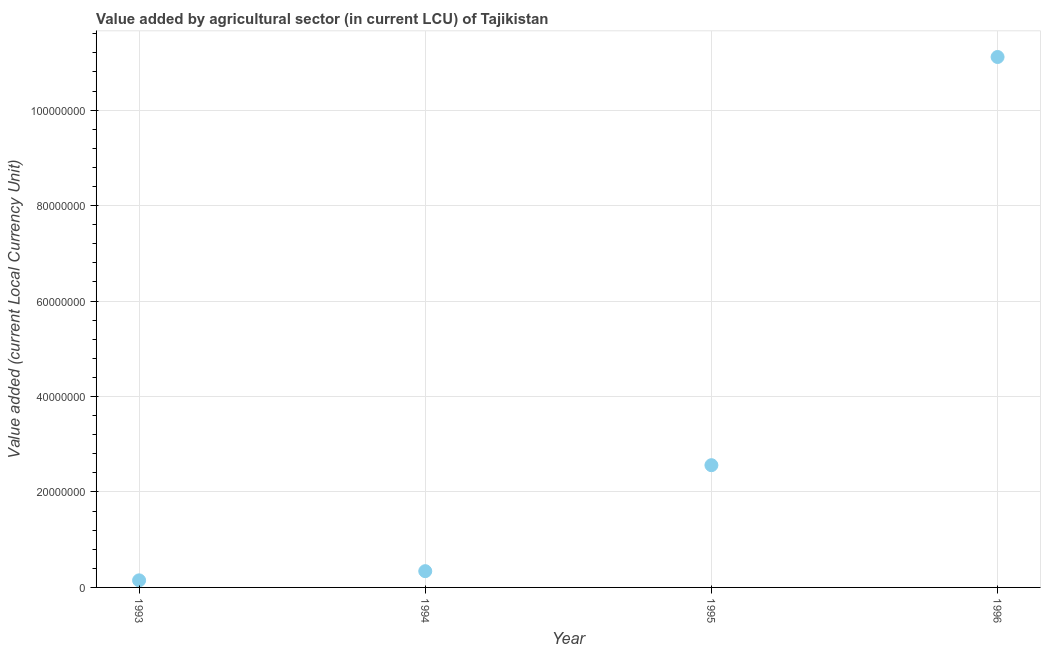What is the value added by agriculture sector in 1994?
Your answer should be very brief. 3.41e+06. Across all years, what is the maximum value added by agriculture sector?
Offer a very short reply. 1.11e+08. Across all years, what is the minimum value added by agriculture sector?
Offer a very short reply. 1.48e+06. In which year was the value added by agriculture sector minimum?
Ensure brevity in your answer.  1993. What is the sum of the value added by agriculture sector?
Your response must be concise. 1.42e+08. What is the difference between the value added by agriculture sector in 1993 and 1995?
Your answer should be very brief. -2.41e+07. What is the average value added by agriculture sector per year?
Ensure brevity in your answer.  3.54e+07. What is the median value added by agriculture sector?
Your response must be concise. 1.45e+07. In how many years, is the value added by agriculture sector greater than 104000000 LCU?
Give a very brief answer. 1. What is the ratio of the value added by agriculture sector in 1993 to that in 1996?
Provide a succinct answer. 0.01. Is the value added by agriculture sector in 1995 less than that in 1996?
Your answer should be very brief. Yes. Is the difference between the value added by agriculture sector in 1993 and 1995 greater than the difference between any two years?
Keep it short and to the point. No. What is the difference between the highest and the second highest value added by agriculture sector?
Provide a succinct answer. 8.55e+07. What is the difference between the highest and the lowest value added by agriculture sector?
Offer a very short reply. 1.10e+08. Does the value added by agriculture sector monotonically increase over the years?
Keep it short and to the point. Yes. How many dotlines are there?
Ensure brevity in your answer.  1. How many years are there in the graph?
Provide a succinct answer. 4. What is the difference between two consecutive major ticks on the Y-axis?
Keep it short and to the point. 2.00e+07. Are the values on the major ticks of Y-axis written in scientific E-notation?
Ensure brevity in your answer.  No. Does the graph contain any zero values?
Give a very brief answer. No. What is the title of the graph?
Offer a very short reply. Value added by agricultural sector (in current LCU) of Tajikistan. What is the label or title of the X-axis?
Your response must be concise. Year. What is the label or title of the Y-axis?
Your response must be concise. Value added (current Local Currency Unit). What is the Value added (current Local Currency Unit) in 1993?
Provide a short and direct response. 1.48e+06. What is the Value added (current Local Currency Unit) in 1994?
Your answer should be very brief. 3.41e+06. What is the Value added (current Local Currency Unit) in 1995?
Ensure brevity in your answer.  2.56e+07. What is the Value added (current Local Currency Unit) in 1996?
Offer a terse response. 1.11e+08. What is the difference between the Value added (current Local Currency Unit) in 1993 and 1994?
Give a very brief answer. -1.92e+06. What is the difference between the Value added (current Local Currency Unit) in 1993 and 1995?
Give a very brief answer. -2.41e+07. What is the difference between the Value added (current Local Currency Unit) in 1993 and 1996?
Your response must be concise. -1.10e+08. What is the difference between the Value added (current Local Currency Unit) in 1994 and 1995?
Your answer should be compact. -2.22e+07. What is the difference between the Value added (current Local Currency Unit) in 1994 and 1996?
Provide a short and direct response. -1.08e+08. What is the difference between the Value added (current Local Currency Unit) in 1995 and 1996?
Your answer should be compact. -8.55e+07. What is the ratio of the Value added (current Local Currency Unit) in 1993 to that in 1994?
Offer a terse response. 0.43. What is the ratio of the Value added (current Local Currency Unit) in 1993 to that in 1995?
Offer a very short reply. 0.06. What is the ratio of the Value added (current Local Currency Unit) in 1993 to that in 1996?
Offer a terse response. 0.01. What is the ratio of the Value added (current Local Currency Unit) in 1994 to that in 1995?
Ensure brevity in your answer.  0.13. What is the ratio of the Value added (current Local Currency Unit) in 1994 to that in 1996?
Give a very brief answer. 0.03. What is the ratio of the Value added (current Local Currency Unit) in 1995 to that in 1996?
Make the answer very short. 0.23. 